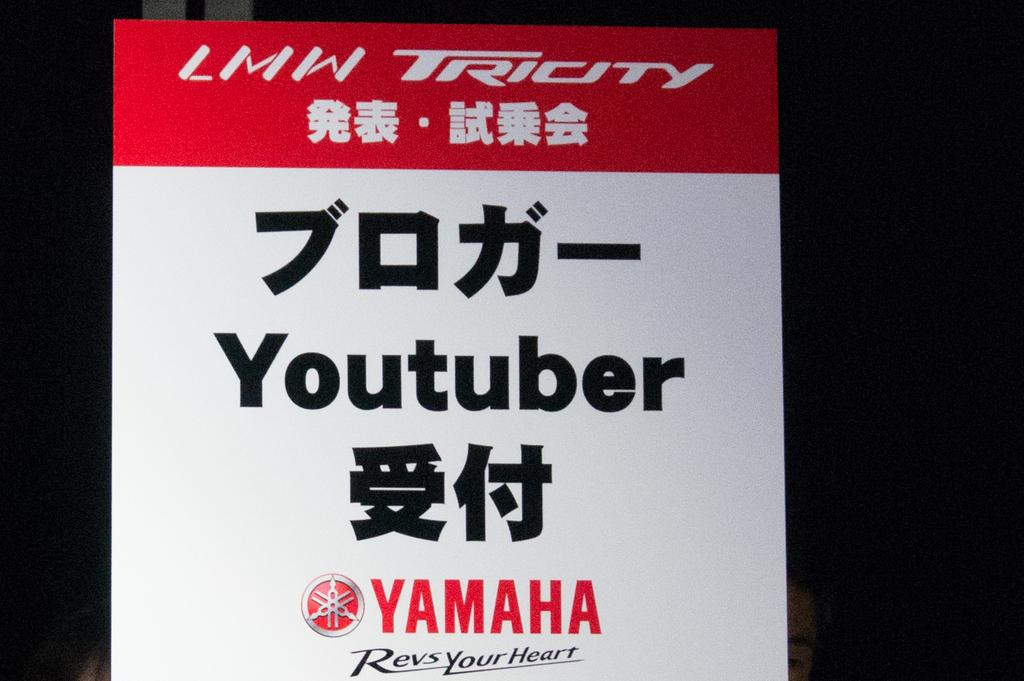Provide a one-sentence caption for the provided image. A white and red Yamaha endorsement for a YouTuber sign. 